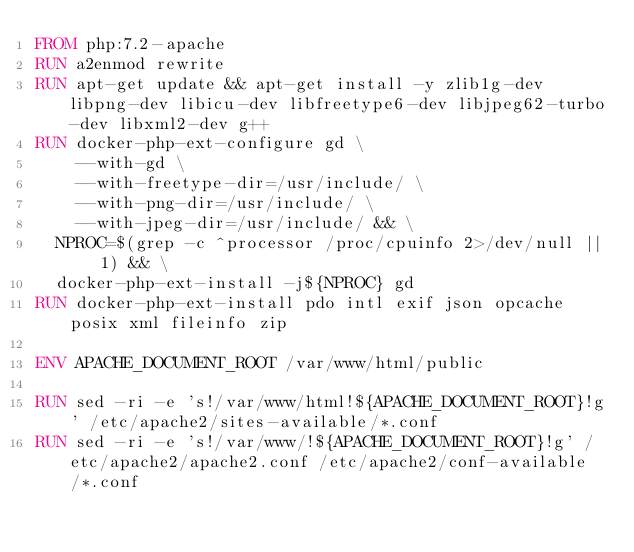<code> <loc_0><loc_0><loc_500><loc_500><_Dockerfile_>FROM php:7.2-apache
RUN a2enmod rewrite
RUN apt-get update && apt-get install -y zlib1g-dev libpng-dev libicu-dev libfreetype6-dev libjpeg62-turbo-dev libxml2-dev g++
RUN docker-php-ext-configure gd \
    --with-gd \
    --with-freetype-dir=/usr/include/ \
    --with-png-dir=/usr/include/ \
    --with-jpeg-dir=/usr/include/ && \
  NPROC=$(grep -c ^processor /proc/cpuinfo 2>/dev/null || 1) && \
  docker-php-ext-install -j${NPROC} gd
RUN docker-php-ext-install pdo intl exif json opcache posix xml fileinfo zip

ENV APACHE_DOCUMENT_ROOT /var/www/html/public

RUN sed -ri -e 's!/var/www/html!${APACHE_DOCUMENT_ROOT}!g' /etc/apache2/sites-available/*.conf
RUN sed -ri -e 's!/var/www/!${APACHE_DOCUMENT_ROOT}!g' /etc/apache2/apache2.conf /etc/apache2/conf-available/*.conf
</code> 